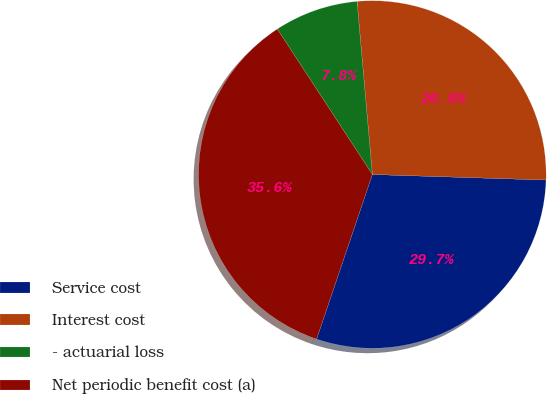<chart> <loc_0><loc_0><loc_500><loc_500><pie_chart><fcel>Service cost<fcel>Interest cost<fcel>- actuarial loss<fcel>Net periodic benefit cost (a)<nl><fcel>29.69%<fcel>26.91%<fcel>7.81%<fcel>35.59%<nl></chart> 